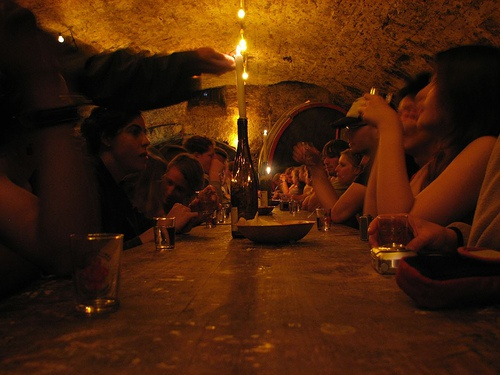Describe the objects in this image and their specific colors. I can see dining table in black, maroon, and brown tones, people in black and maroon tones, people in black, maroon, and brown tones, people in black, maroon, and brown tones, and people in black, maroon, and brown tones in this image. 